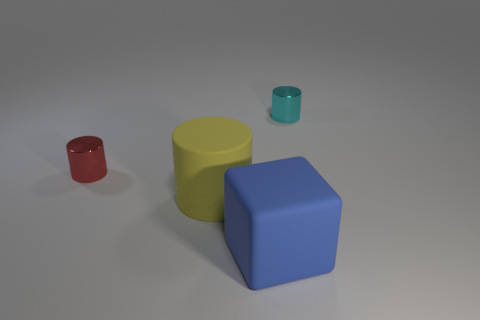Subtract all tiny cyan cylinders. How many cylinders are left? 2 Add 2 red things. How many objects exist? 6 Subtract all cubes. How many objects are left? 3 Subtract all yellow cylinders. Subtract all cyan spheres. How many cylinders are left? 2 Subtract all large matte cylinders. Subtract all tiny red things. How many objects are left? 2 Add 1 small cyan metallic things. How many small cyan metallic things are left? 2 Add 4 tiny things. How many tiny things exist? 6 Subtract 0 blue spheres. How many objects are left? 4 